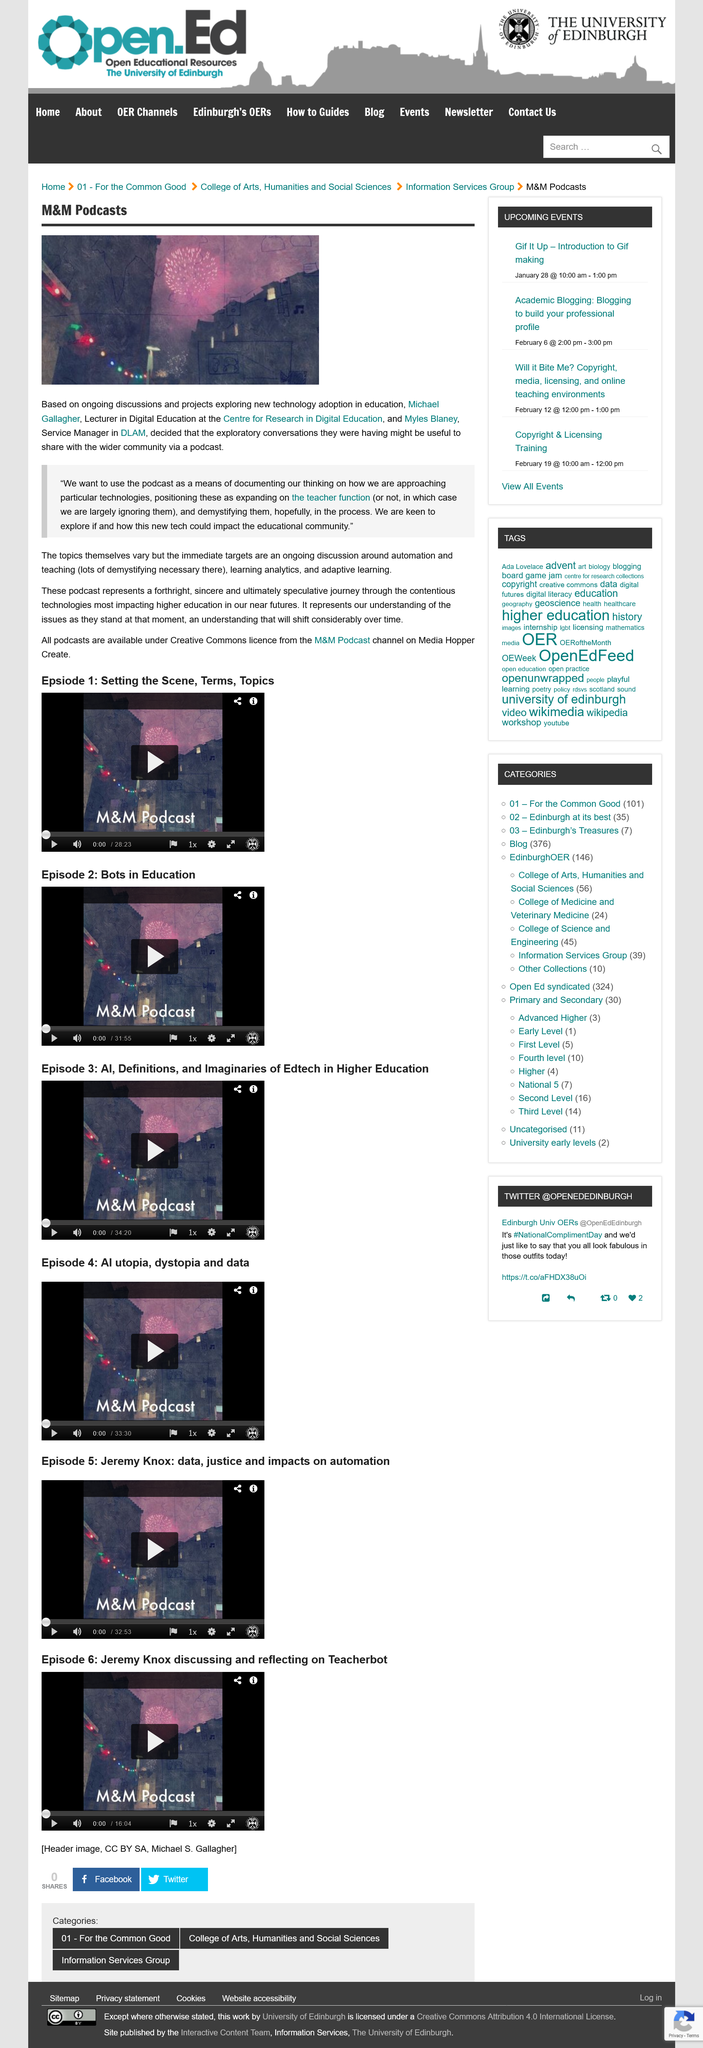Highlight a few significant elements in this photo. The podcasts primarily cover the topics of automation, teaching and learning analytics, and adaptive learning, which are relevant to higher education. The M&M Podcast channel on Media Hopper Create provides its podcasts under a Creative Commons license, making them available for public use and access. The individuals who are responsible for producing the podcasts are Michael Gallagher and Myles Blaney. 